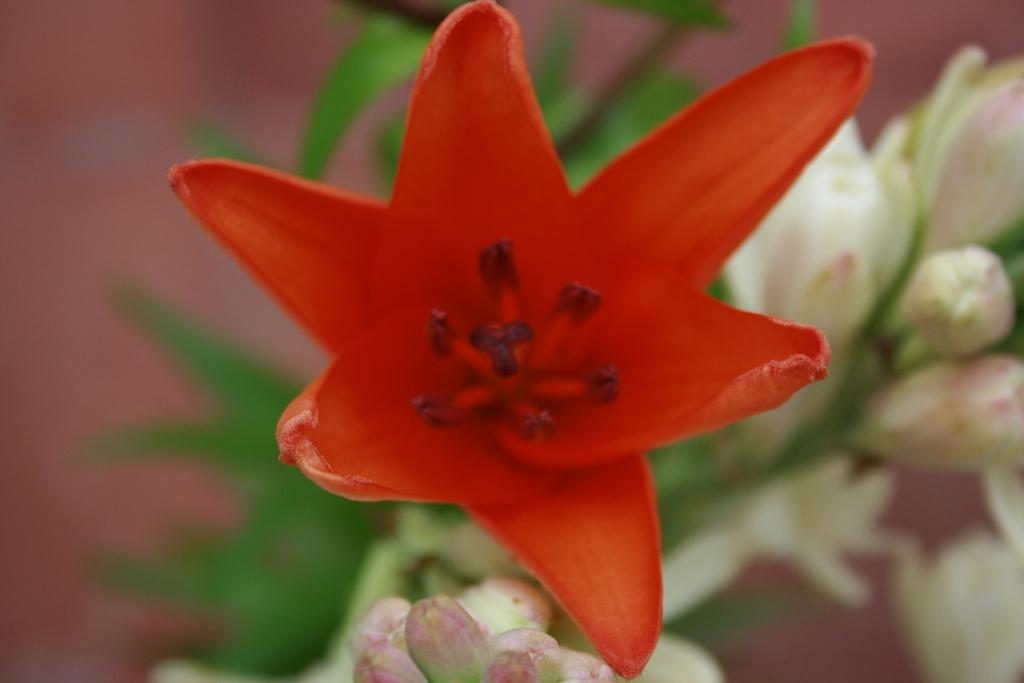What type of plant is visible in the image? There is a plant in the image. What additional features can be seen on the plant? There are flowers in the image. Can you describe the background of the image? The background of the image is blurred. What type of maid is visible in the image? There is no maid present in the image. How does the basin help the plant grow in the image? There is no basin present in the image, and therefore it cannot help the plant grow. 